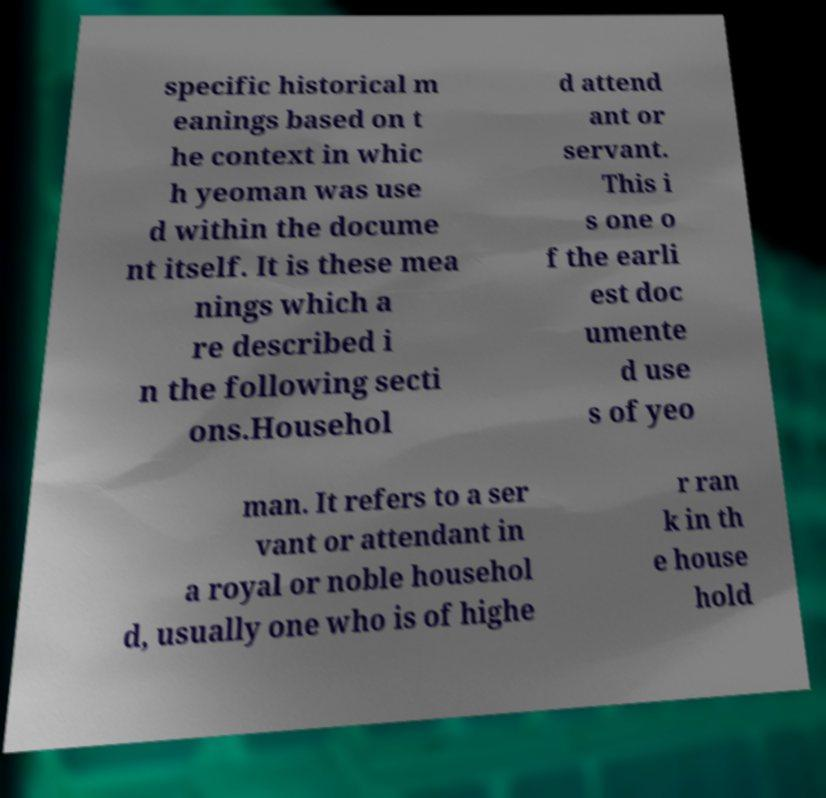I need the written content from this picture converted into text. Can you do that? specific historical m eanings based on t he context in whic h yeoman was use d within the docume nt itself. It is these mea nings which a re described i n the following secti ons.Househol d attend ant or servant. This i s one o f the earli est doc umente d use s of yeo man. It refers to a ser vant or attendant in a royal or noble househol d, usually one who is of highe r ran k in th e house hold 